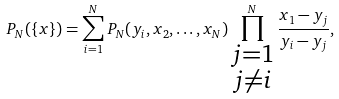Convert formula to latex. <formula><loc_0><loc_0><loc_500><loc_500>P _ { N } ( \{ x \} ) = \sum _ { i = 1 } ^ { N } P _ { N } ( y _ { i } , x _ { 2 } , \dots , x _ { N } ) \prod _ { \substack { j = 1 \\ j \neq i } } ^ { N } \frac { x _ { 1 } - y _ { j } } { y _ { i } - y _ { j } } ,</formula> 